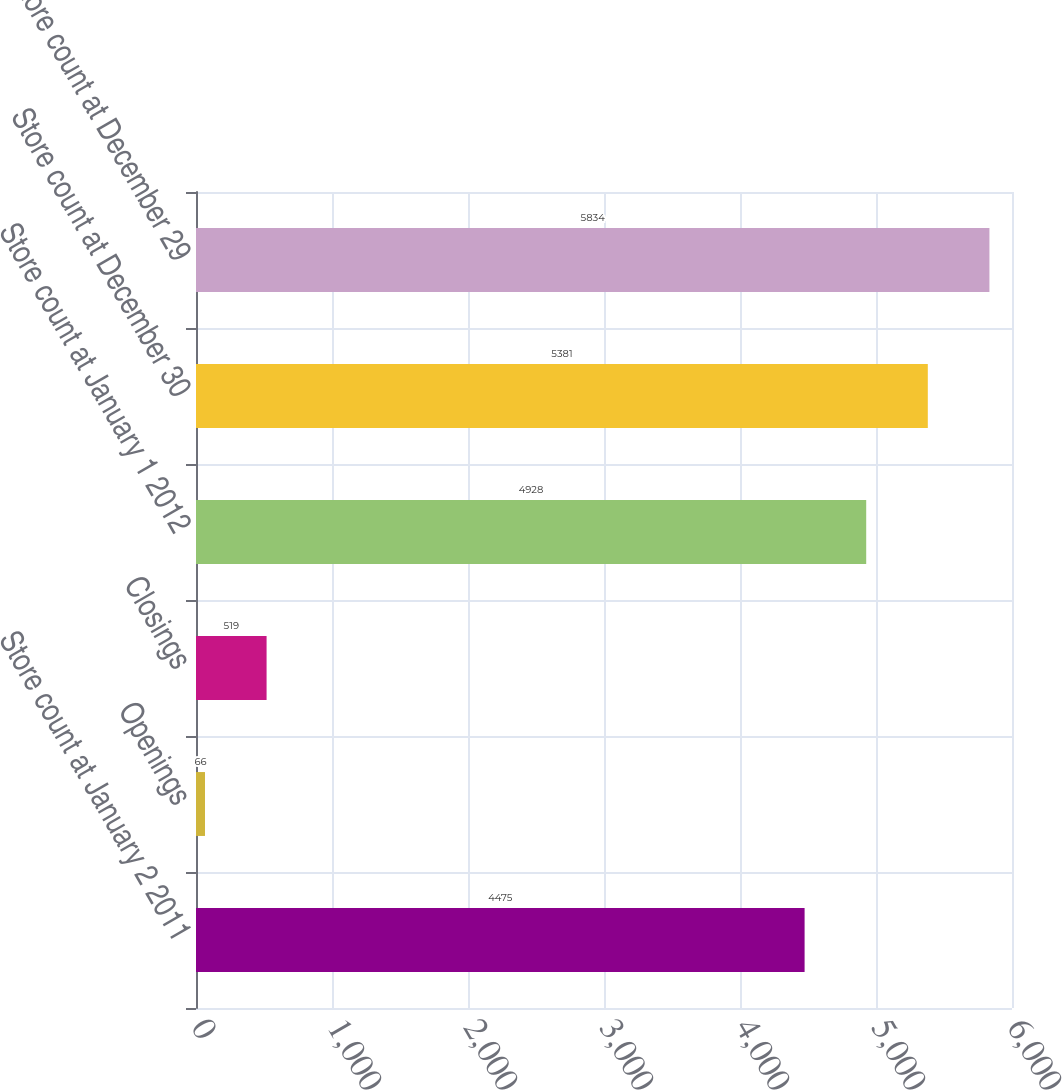Convert chart. <chart><loc_0><loc_0><loc_500><loc_500><bar_chart><fcel>Store count at January 2 2011<fcel>Openings<fcel>Closings<fcel>Store count at January 1 2012<fcel>Store count at December 30<fcel>Store count at December 29<nl><fcel>4475<fcel>66<fcel>519<fcel>4928<fcel>5381<fcel>5834<nl></chart> 